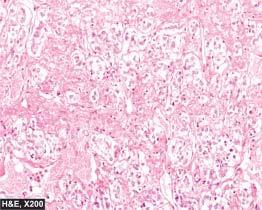what has typical zellballen or nested pattern?
Answer the question using a single word or phrase. Tumour 